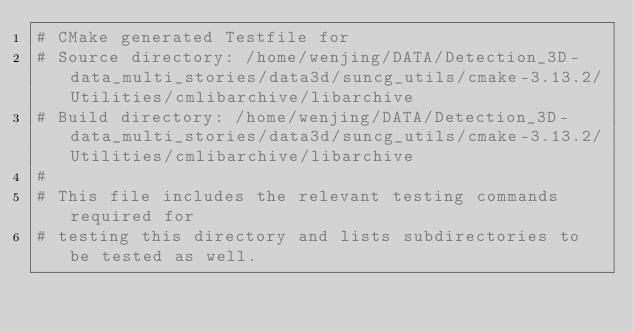Convert code to text. <code><loc_0><loc_0><loc_500><loc_500><_CMake_># CMake generated Testfile for 
# Source directory: /home/wenjing/DATA/Detection_3D-data_multi_stories/data3d/suncg_utils/cmake-3.13.2/Utilities/cmlibarchive/libarchive
# Build directory: /home/wenjing/DATA/Detection_3D-data_multi_stories/data3d/suncg_utils/cmake-3.13.2/Utilities/cmlibarchive/libarchive
# 
# This file includes the relevant testing commands required for 
# testing this directory and lists subdirectories to be tested as well.
</code> 